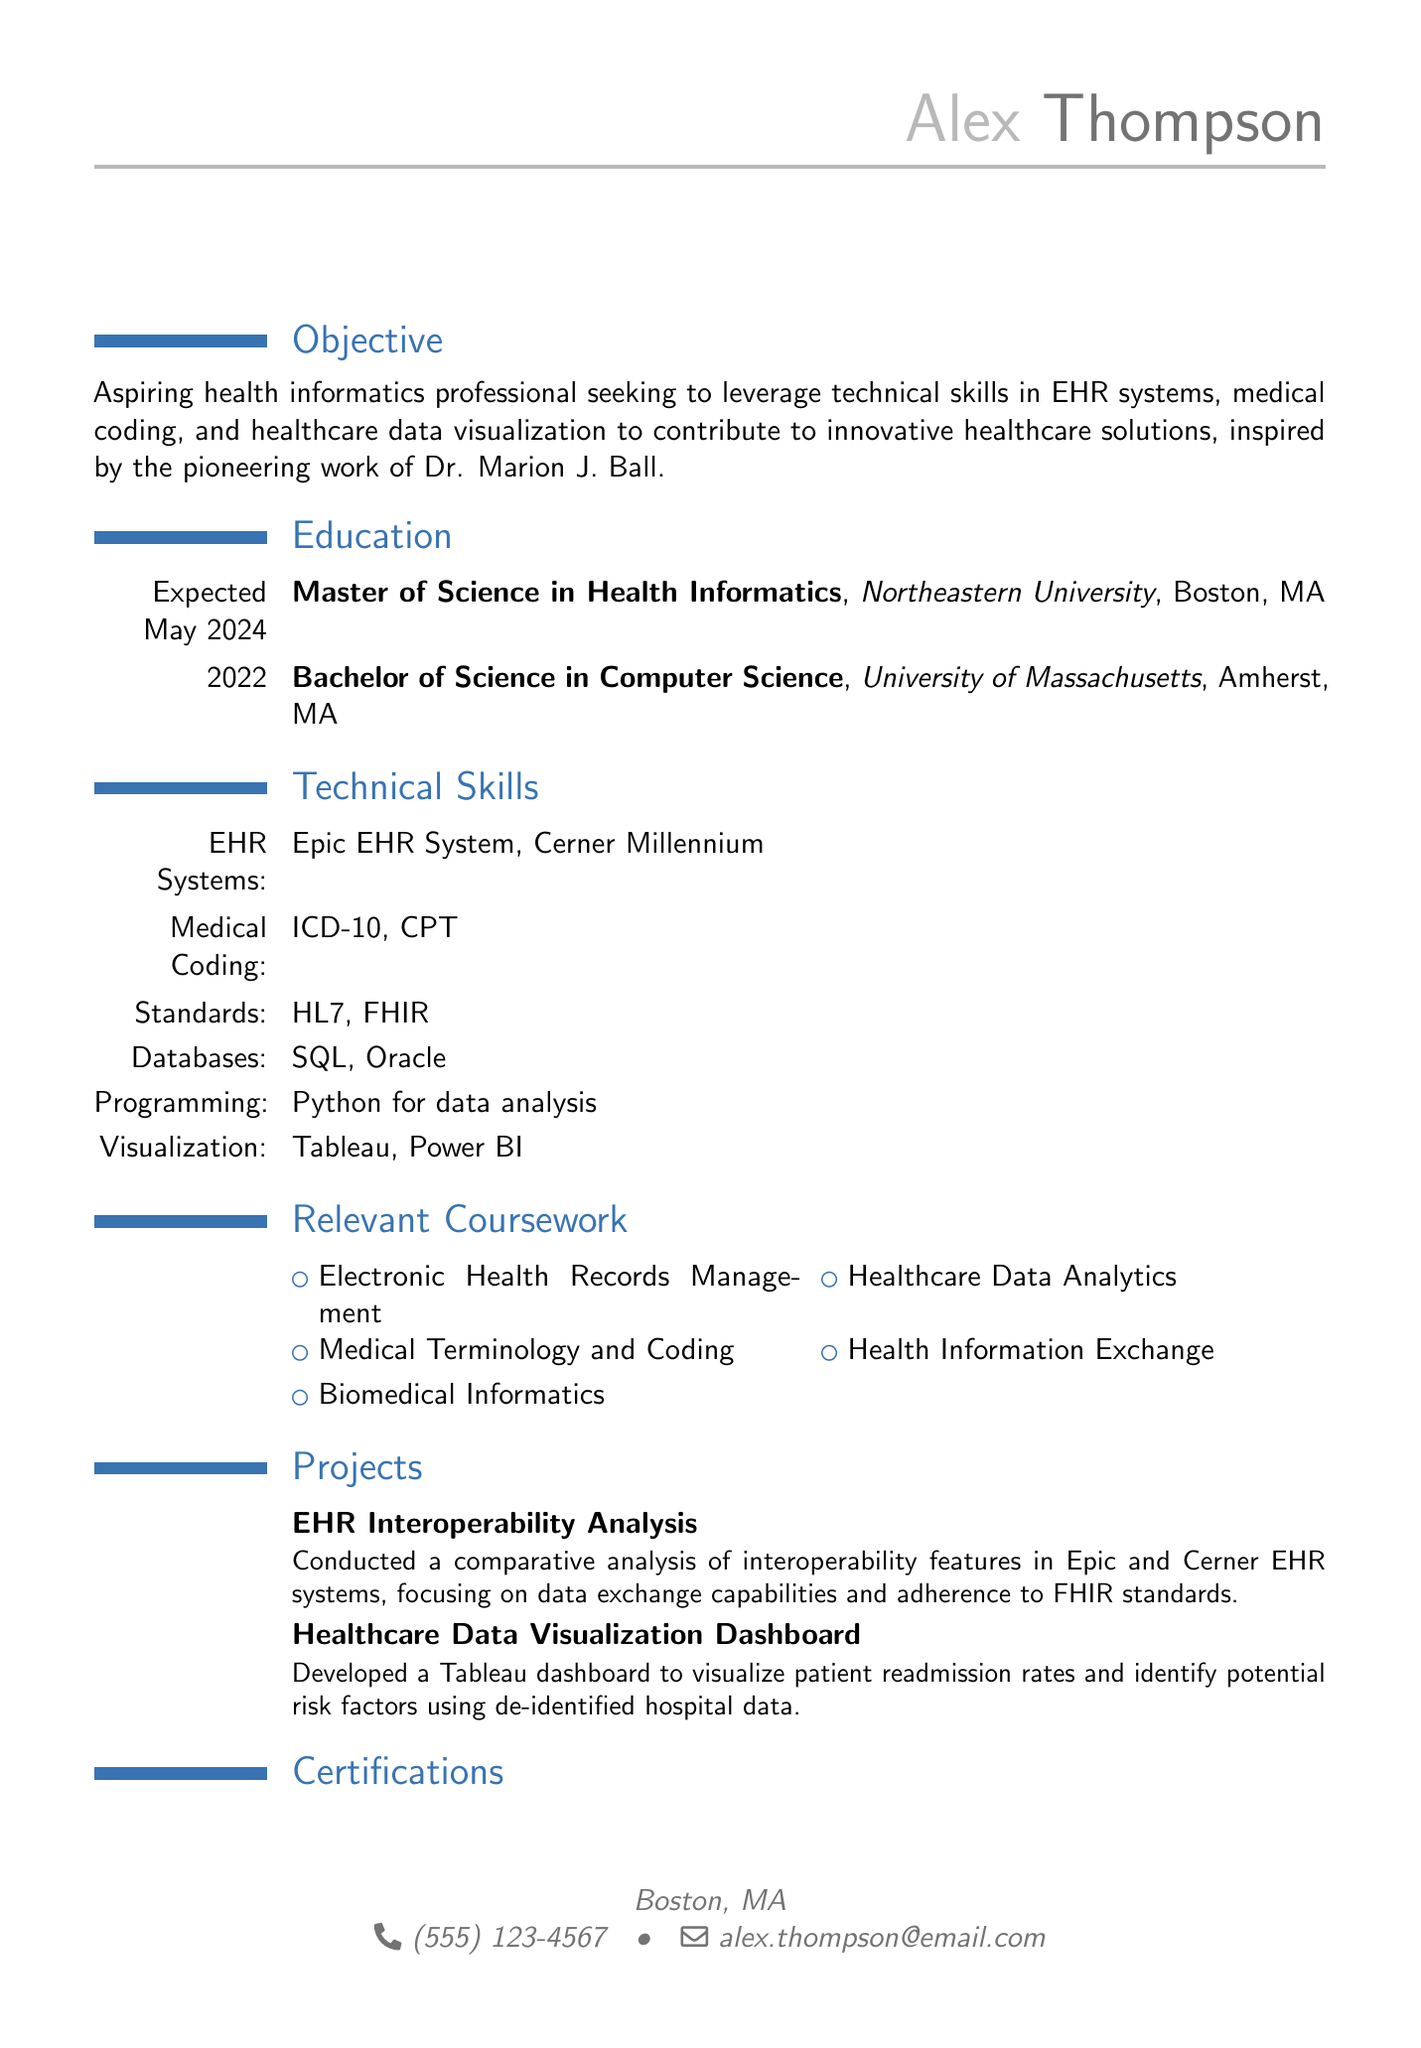What is the name of the individual? The name is listed at the top of the document under personal information.
Answer: Alex Thompson What degree is expected to be completed by May 2024? The document outlines the educational background, including degrees and their expected completion dates.
Answer: Master of Science in Health Informatics What technical skill is associated with EHR systems? The technical skills section lists specific skills related to EHR systems.
Answer: Epic EHR System How many projects are listed in the CV? The projects section provides the titles of the projects undertaken by the individual.
Answer: 2 Which certification is mentioned first? The certifications section lists qualifications in the order presented in the document.
Answer: Certified Associate in Healthcare Information and Management Systems (CAHIMS) What is the location of the individual? The personal information section includes the current address of the individual.
Answer: Boston, MA What is the focus of the EHR Interoperability Analysis project? The project descriptions summarize the aims and focus areas of individual projects mentioned in the CV.
Answer: Interoperability features in Epic and Cerner EHR systems Which database technologies are mentioned? The technical skills section highlights specific technologies used in the field.
Answer: SQL and Oracle databases 